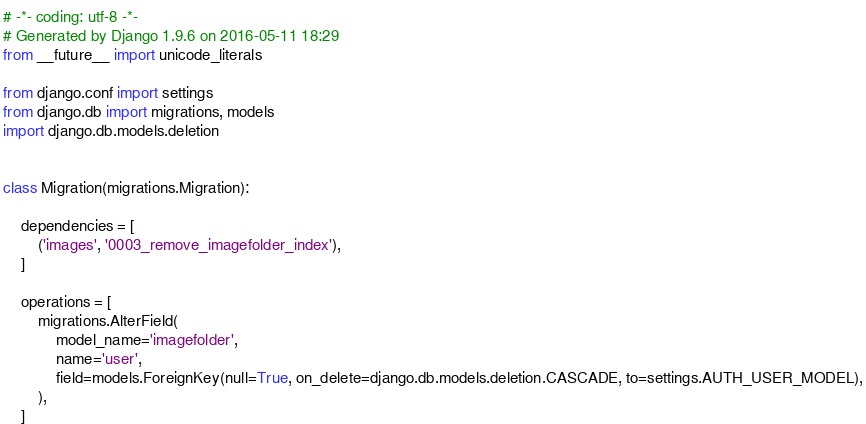Convert code to text. <code><loc_0><loc_0><loc_500><loc_500><_Python_># -*- coding: utf-8 -*-
# Generated by Django 1.9.6 on 2016-05-11 18:29
from __future__ import unicode_literals

from django.conf import settings
from django.db import migrations, models
import django.db.models.deletion


class Migration(migrations.Migration):

    dependencies = [
        ('images', '0003_remove_imagefolder_index'),
    ]

    operations = [
        migrations.AlterField(
            model_name='imagefolder',
            name='user',
            field=models.ForeignKey(null=True, on_delete=django.db.models.deletion.CASCADE, to=settings.AUTH_USER_MODEL),
        ),
    ]
</code> 